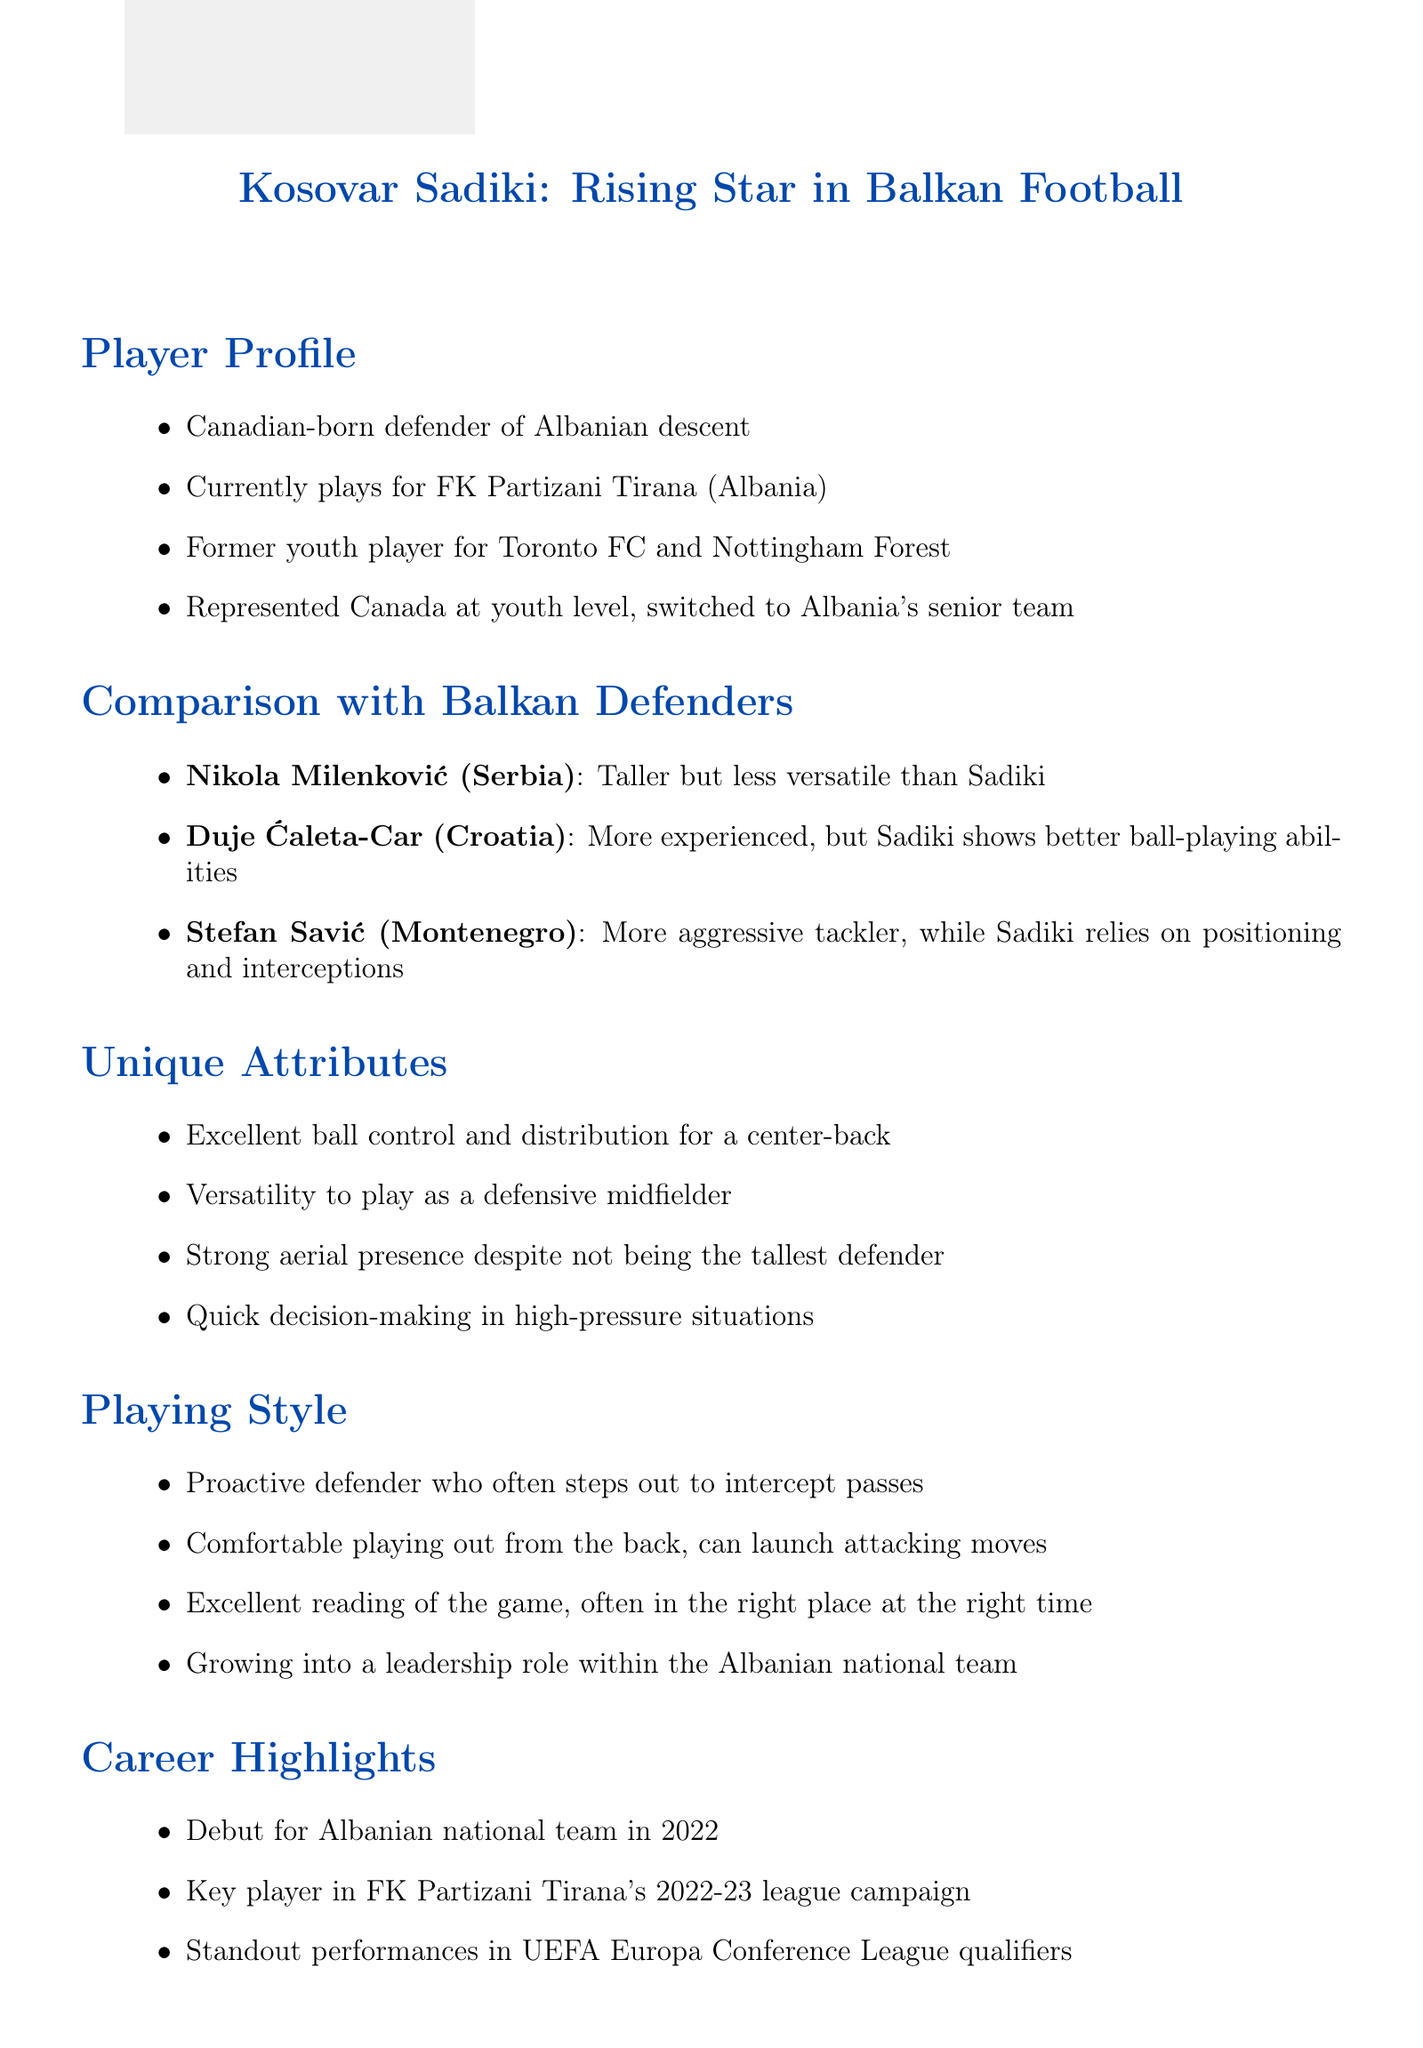What is Kosovar Sadiki's current team? The document states that Kosovar Sadiki currently plays for FK Partizani Tirana.
Answer: FK Partizani Tirana What is Sadiki's unique attribute related to ball skills? One of Sadiki's unique attributes mentioned is his excellent ball control and distribution for a center-back.
Answer: Excellent ball control and distribution Who is compared to Sadiki for being more aggressive? The document mentions Stefan Savić as a more aggressive tackler than Sadiki.
Answer: Stefan Savić In which year did Sadiki make his debut for the Albanian national team? The document indicates that Sadiki's debut for the Albanian national team was in 2022.
Answer: 2022 Which former Albania captain provided an opinion on Sadiki? The document quotes Lorik Cana, who is identified as a former Albania captain.
Answer: Lorik Cana What is one area for improvement noted for Sadiki? According to the document, one area for improvement for Sadiki is handling of high-pressing opponents.
Answer: Handling of high-pressing opponents Which country does Duje Ćaleta-Car represent? Duje Ćaleta-Car is noted as representing Croatia in the document.
Answer: Croatia What is Sadiki's defensive approach described as? The document describes Sadiki's defensive approach as that of a proactive defender.
Answer: Proactive defender What type of player was Sadiki before joining FK Partizani Tirana? The document states that Sadiki was a former youth player for Toronto FC and Nottingham Forest.
Answer: Former youth player 